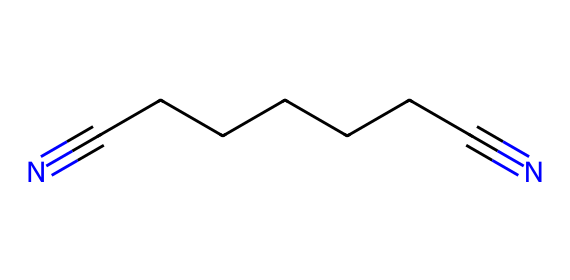What is the molecular formula of adiponitrile? The SMILES representation of adiponitrile shows two cyano groups (–C≡N) at each end of a seven-carbon chain (–CCCCCCC–). Counting the atoms gives us a total of 8 carbon atoms and 10 hydrogen atoms, along with 2 nitrogen atoms. Hence, the molecular formula is C8H10N2.
Answer: C8H10N2 How many carbon atoms are in the structure? By analyzing the SMILES representation, we see a continuous chain of seven carbon atoms plus the effect of the terminal carbons in the nitrile groups. Thus, there are a total of 8 carbon atoms.
Answer: 8 Which functional groups are present in adiponitrile? The structure reveals the presence of two cyano groups (–C≡N) at each end of the carbon chain, which are characteristic of nitriles. No other functional groups are present in this structure.
Answer: cyano groups What is the role of adiponitrile in nylon manufacturing? Adiponitrile serves as a key precursor in the synthesis of nylon-6,6, which is a type of nylon polymer. It provides the necessary carbon chain and nitrogen atoms for the polymerization process.
Answer: nylon precursor How does the structure of adiponitrile indicate its classification as a nitrile? The presence of the cyano groups (–C≡N) within the structure indicates that adiponitrile belongs to the nitrile class. By definition, nitriles contain one or more cyano groups attached to the carbon chain, which aligns with what is seen in the SMILES representation.
Answer: cyano groups 